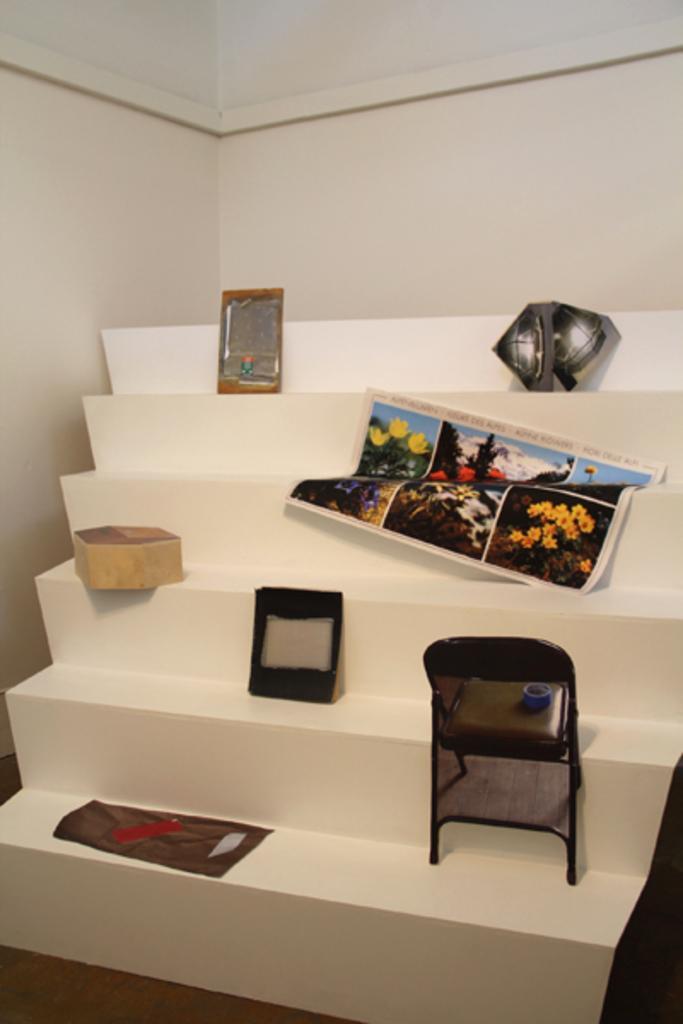Could you give a brief overview of what you see in this image? In this picture there are electronics. 